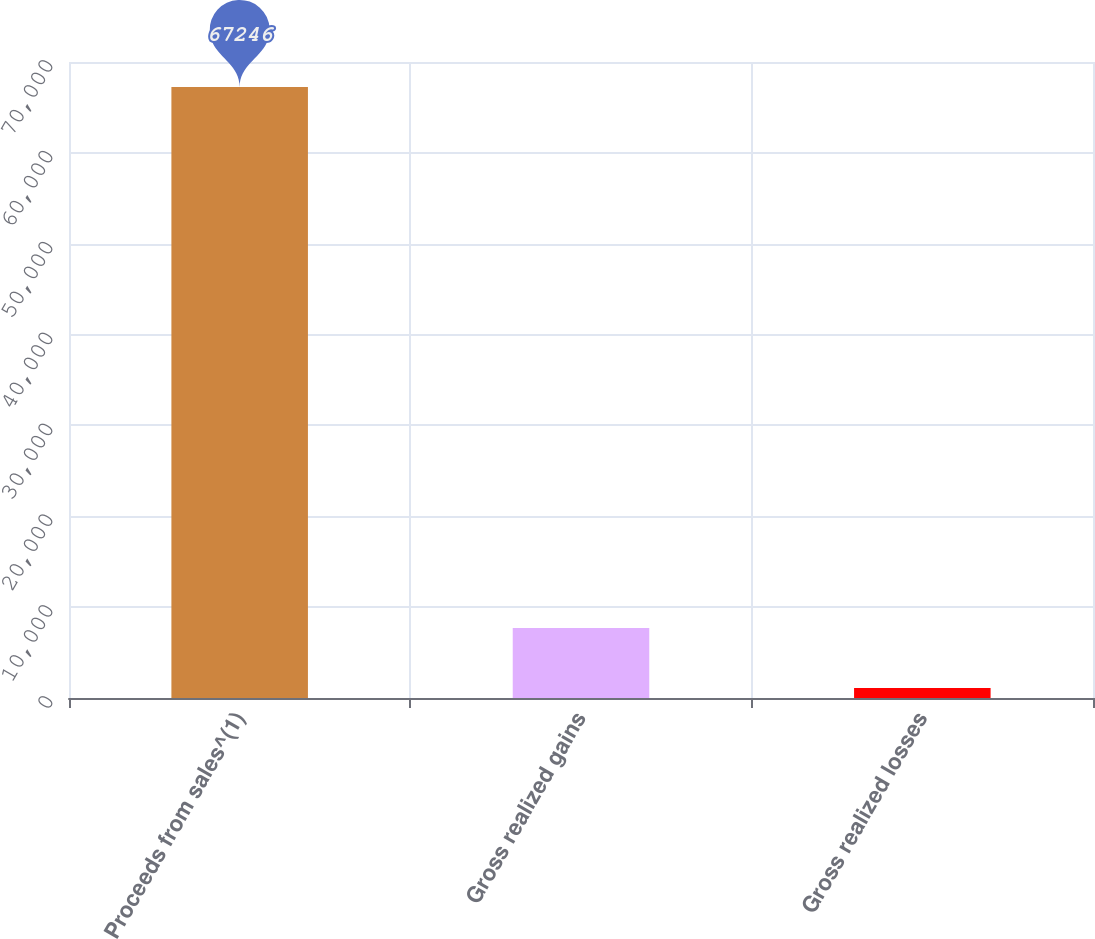Convert chart to OTSL. <chart><loc_0><loc_0><loc_500><loc_500><bar_chart><fcel>Proceeds from sales^(1)<fcel>Gross realized gains<fcel>Gross realized losses<nl><fcel>67246<fcel>7714.6<fcel>1100<nl></chart> 